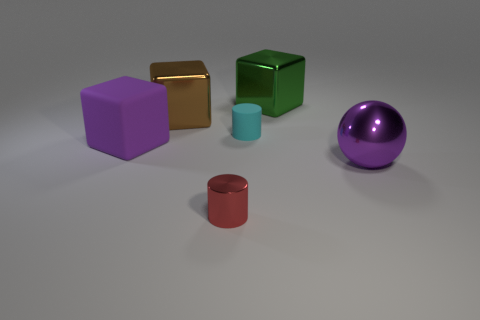How many metal things are large cyan balls or cyan objects?
Your response must be concise. 0. Are there any other things that are the same material as the green cube?
Provide a short and direct response. Yes. Is there a red thing on the left side of the purple thing that is left of the big purple shiny object?
Your response must be concise. No. What number of things are big cubes that are to the left of the green object or big metal blocks behind the big brown object?
Ensure brevity in your answer.  3. Is there anything else that is the same color as the big matte thing?
Make the answer very short. Yes. There is a shiny block right of the large metallic object left of the tiny cylinder that is to the left of the cyan rubber thing; what is its color?
Keep it short and to the point. Green. There is a metal sphere that is in front of the large metal block on the left side of the matte cylinder; what size is it?
Ensure brevity in your answer.  Large. What is the thing that is in front of the matte block and to the left of the purple metallic object made of?
Make the answer very short. Metal. There is a metal ball; is it the same size as the rubber object left of the large brown block?
Provide a short and direct response. Yes. Is there a large metal ball?
Ensure brevity in your answer.  Yes. 